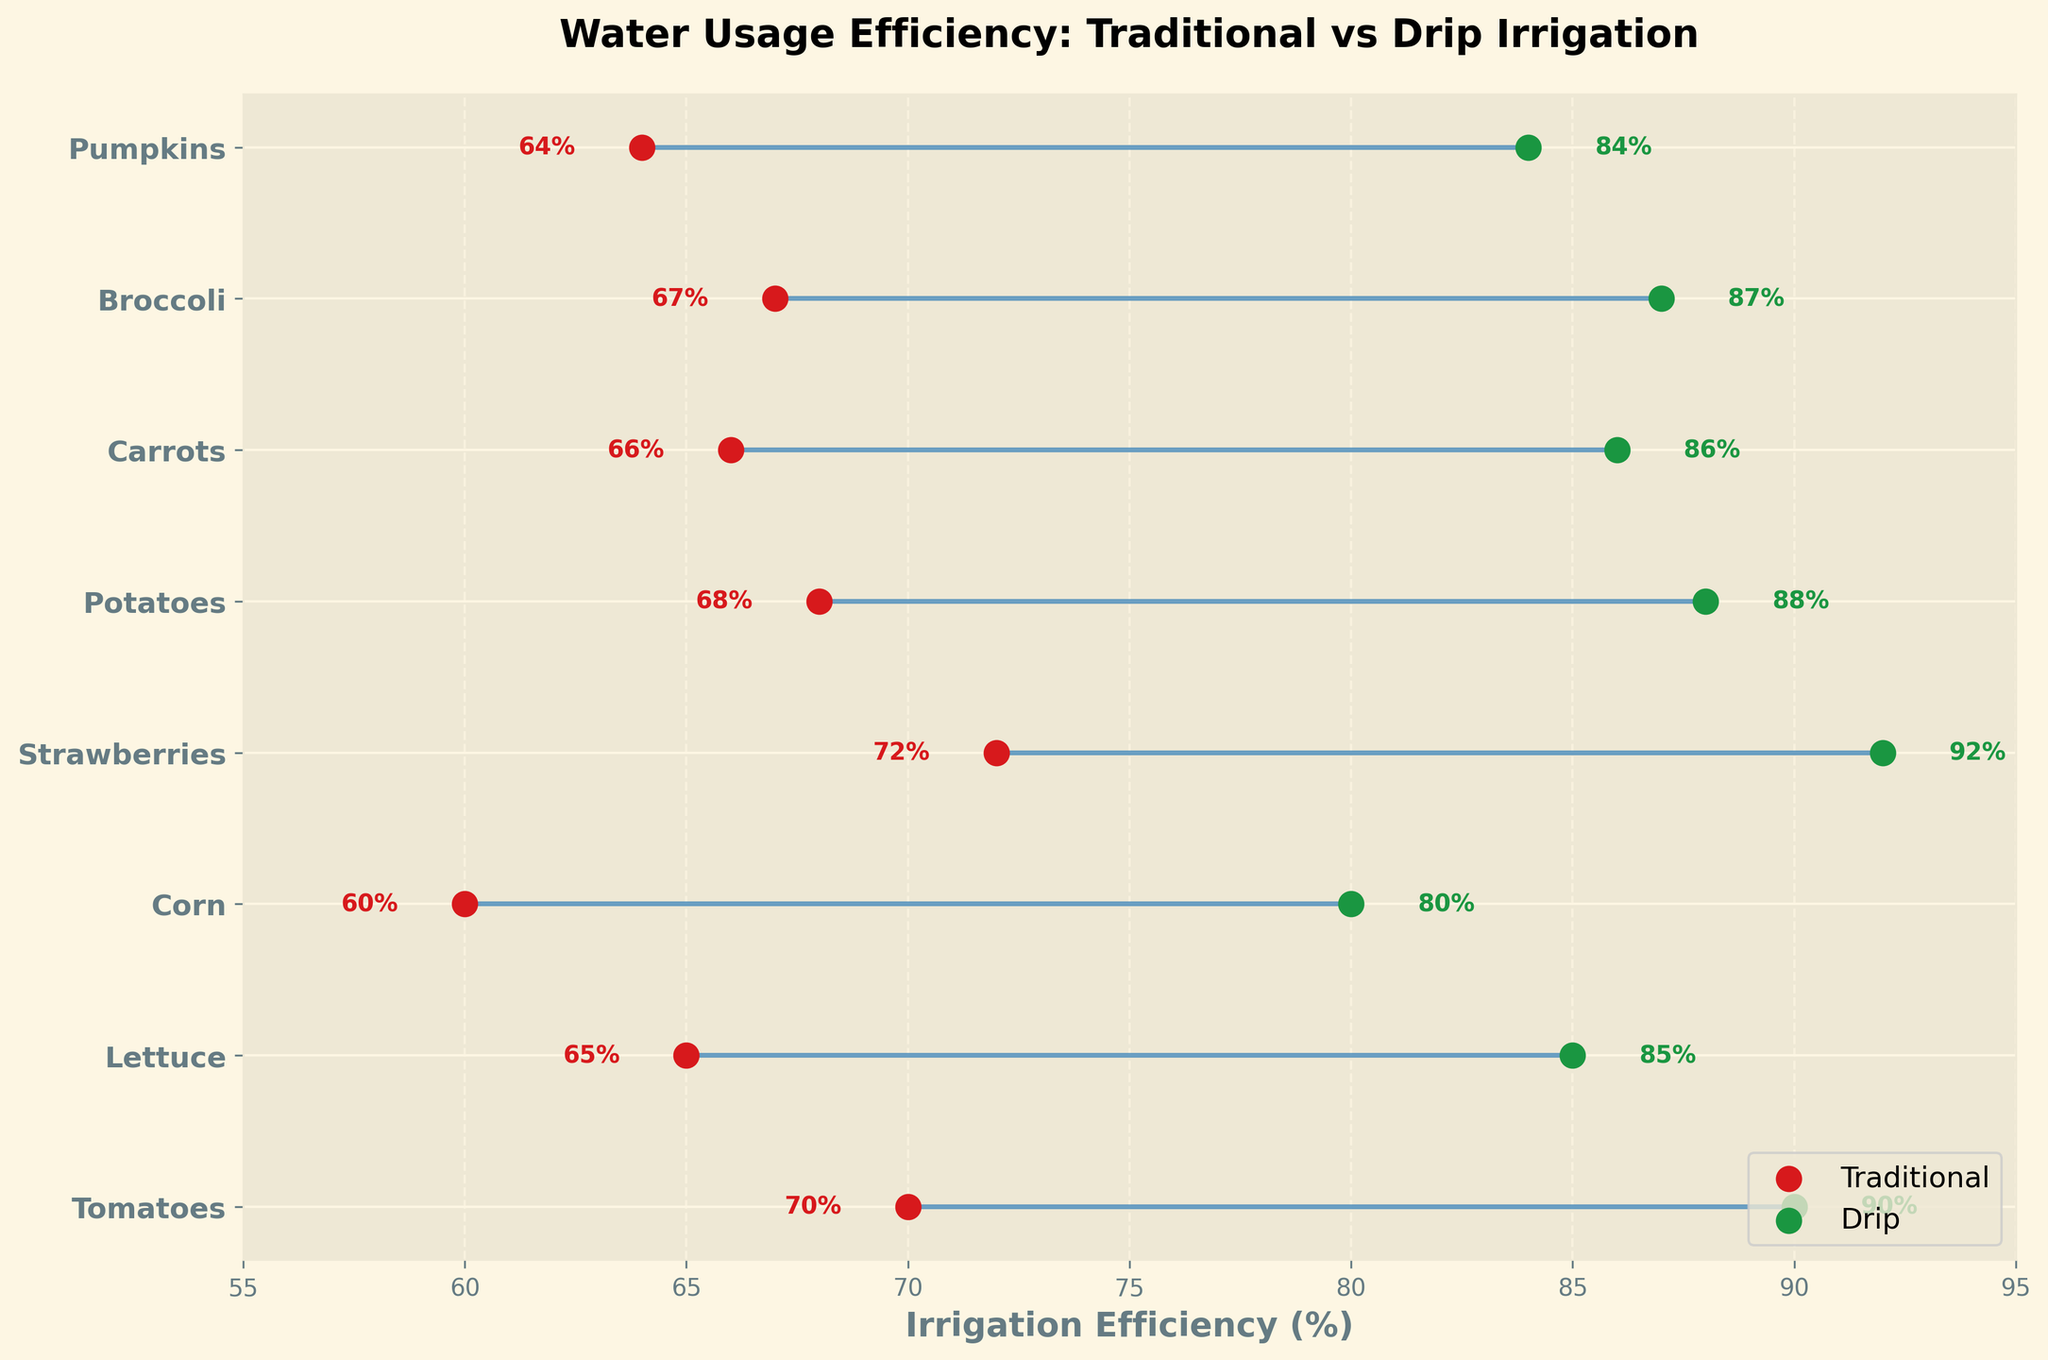What is the title of the plot? The title is usually displayed at the top of the figure.
Answer: Water Usage Efficiency: Traditional vs Drip Irrigation What is the color of the points representing traditional irrigation? The points representing traditional irrigation are colored in a distinctive shade.
Answer: Red Which crop has the highest efficiency with drip irrigation? Check the green points representing the efficiency of drip irrigation for each crop and identify the highest value.
Answer: Strawberries How many crops are displayed in the plot? Count the number of different crops listed on the y-axis.
Answer: 8 What is the efficiency range for traditional irrigation? Look at the minimum and maximum values of the red points representing traditional irrigation.
Answer: 60% to 72% Which crop has the smallest difference in efficiency between traditional and drip irrigation? Calculate the differences between traditional and drip irrigation efficiencies for all crops and find the smallest.
Answer: Corn Which crop shows the highest increase in efficiency when switching from traditional to drip irrigation? Calculate the differences between traditional and drip irrigation efficiencies for all crops and find the largest.
Answer: Strawberries What is the average efficiency for traditional irrigation for all crops? Sum all the traditional irrigation efficiencies and divide by the number of crops. (70 + 65 + 60 + 72 + 68 + 66 + 67 + 64) / 8 = 66.5
Answer: 66.5% What is the overall trend when comparing traditional and drip irrigation efficiencies? Observe if the drip irrigation efficiencies are consistently higher than traditional irrigation across all crops.
Answer: Drip irrigation is more efficient than traditional irrigation for all crops 